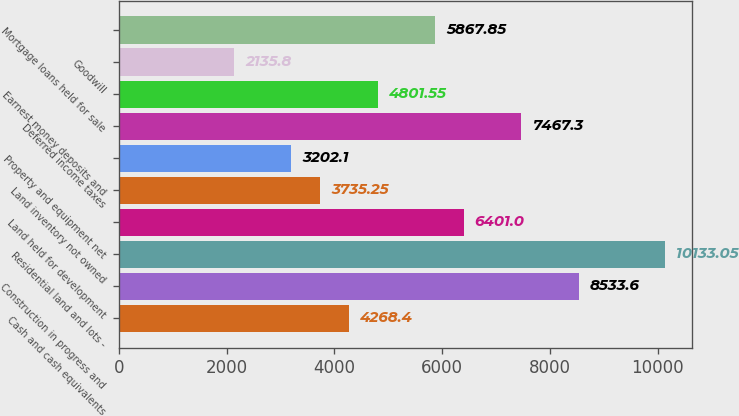<chart> <loc_0><loc_0><loc_500><loc_500><bar_chart><fcel>Cash and cash equivalents<fcel>Construction in progress and<fcel>Residential land and lots -<fcel>Land held for development<fcel>Land inventory not owned<fcel>Property and equipment net<fcel>Deferred income taxes<fcel>Earnest money deposits and<fcel>Goodwill<fcel>Mortgage loans held for sale<nl><fcel>4268.4<fcel>8533.6<fcel>10133<fcel>6401<fcel>3735.25<fcel>3202.1<fcel>7467.3<fcel>4801.55<fcel>2135.8<fcel>5867.85<nl></chart> 